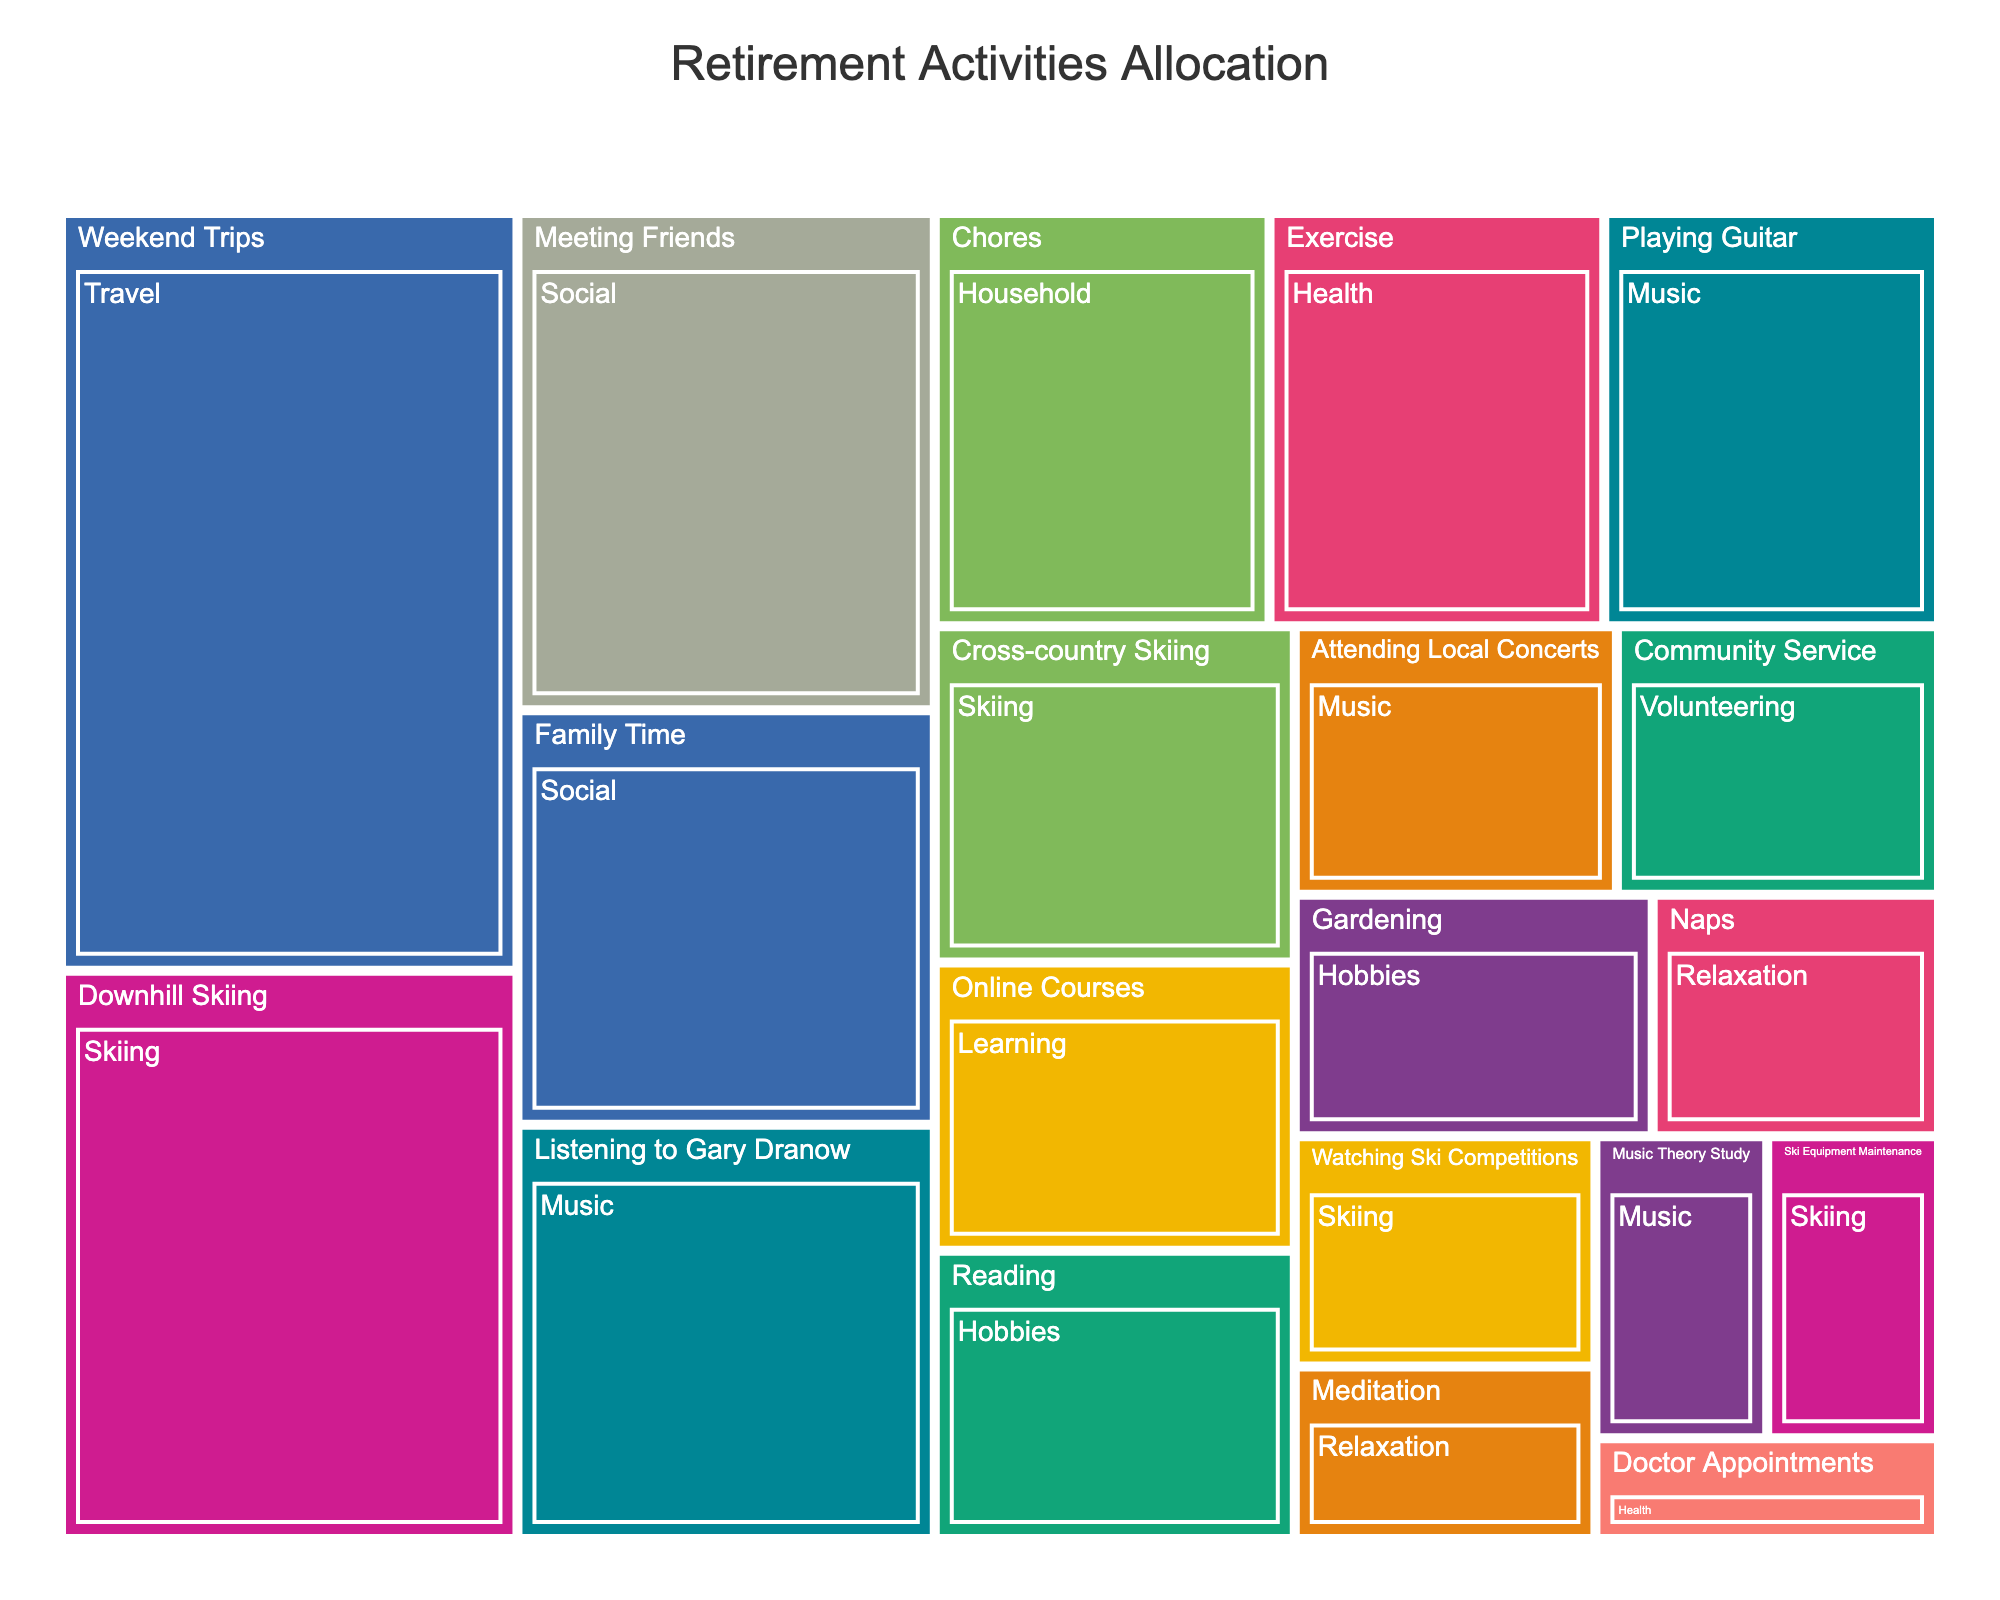What is the largest activity category in terms of hours? By looking at the relative sizes of the categories in the treemap, the largest category by the total number of hours should have the biggest rectangle. "Travel" occupies the largest space.
Answer: Travel How many total hours are allocated to skiing activities? To get the sum of hours allocated to the different skiing activities, sum up all the hours under the Skiing category: 15 (Downhill Skiing) + 7 (Cross-country Skiing) + 3 (Ski Equipment Maintenance) + 4 (Watching Ski Competitions).
Answer: 29 Which specific activity within the music category has the highest allocation of time? Within the Music category, compare the sizes of the rectangles representing different activities. "Listening to Gary Dranow" has the largest rectangle, indicating the highest time allocation.
Answer: Listening to Gary Dranow How many hours are spent on social activities overall? Add up the hours for the activities under the Social category: 12 (Meeting Friends) + 10 (Family Time).
Answer: 22 Which category has the same number of hours as 'Exercise' in the Health category? Find a category where any activity's rectangle matches the size of the 'Exercise' rectangle (8 hours). The "Household" category with "Chores" also has 8 hours.
Answer: Household Is there more time spent on skiing activities or social activities? Compare the sum of hours for skiing activities (15 + 7 + 3 + 4 = 29) and social activities (12 + 10 = 22). Skiing activities involve more time.
Answer: Skiing activities Which activity within the Hobbies category takes up more hours? Within Hobbies, compare the sizes of the rectangles for "Reading" (6 hours) and "Gardening" (5 hours). "Reading" takes up more hours.
Answer: Reading What proportion of hours are spent on attending local concerts compared to playing guitar? Compare the hours for "Attending Local Concerts" (5 hours) and "Playing Guitar" (8 hours) within the Music category. Attending concerts is 5/8 times the hours of playing guitar.
Answer: 5/8 How much more time is spent on weekend trips compared to meditation? Calculate the difference in hours between "Weekend Trips" (20 hours) and "Meditation" (3 hours). 20 - 3 = 17 hours.
Answer: 17 hours Which category has the smallest total allocation of hours? Identify the category with the smallest aggregated area. "Relaxation" (3 for Meditation + 4 for Naps = 7 hours) appears to be the smallest.
Answer: Relaxation 